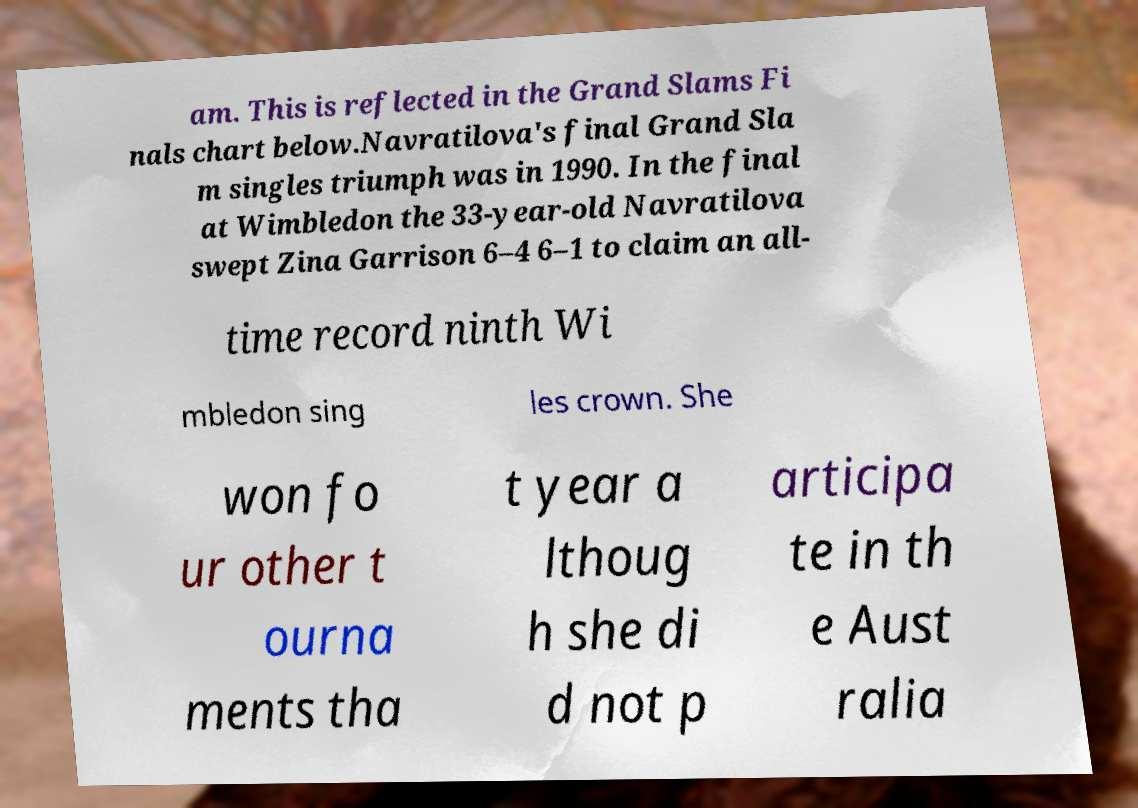Can you accurately transcribe the text from the provided image for me? am. This is reflected in the Grand Slams Fi nals chart below.Navratilova's final Grand Sla m singles triumph was in 1990. In the final at Wimbledon the 33-year-old Navratilova swept Zina Garrison 6–4 6–1 to claim an all- time record ninth Wi mbledon sing les crown. She won fo ur other t ourna ments tha t year a lthoug h she di d not p articipa te in th e Aust ralia 